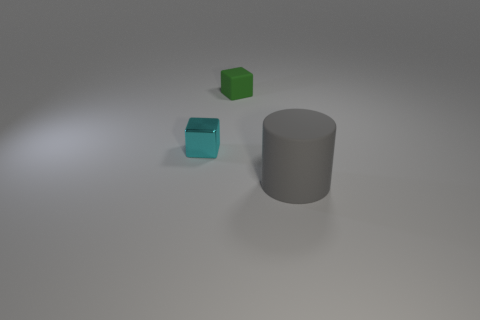Subtract all brown cylinders. Subtract all blue balls. How many cylinders are left? 1 Add 2 rubber objects. How many objects exist? 5 Subtract all cylinders. How many objects are left? 2 Add 1 green rubber cubes. How many green rubber cubes exist? 2 Subtract 0 yellow balls. How many objects are left? 3 Subtract all small blue rubber cylinders. Subtract all tiny green cubes. How many objects are left? 2 Add 2 big gray rubber objects. How many big gray rubber objects are left? 3 